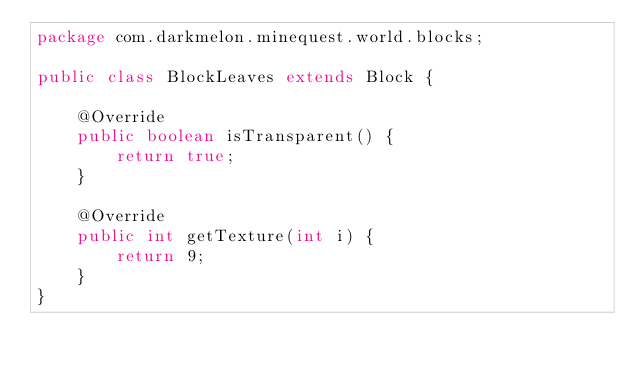Convert code to text. <code><loc_0><loc_0><loc_500><loc_500><_Java_>package com.darkmelon.minequest.world.blocks;

public class BlockLeaves extends Block {

	@Override
	public boolean isTransparent() {
		return true;
	}
	
	@Override
	public int getTexture(int i) {
		return 9;
	}
}
</code> 